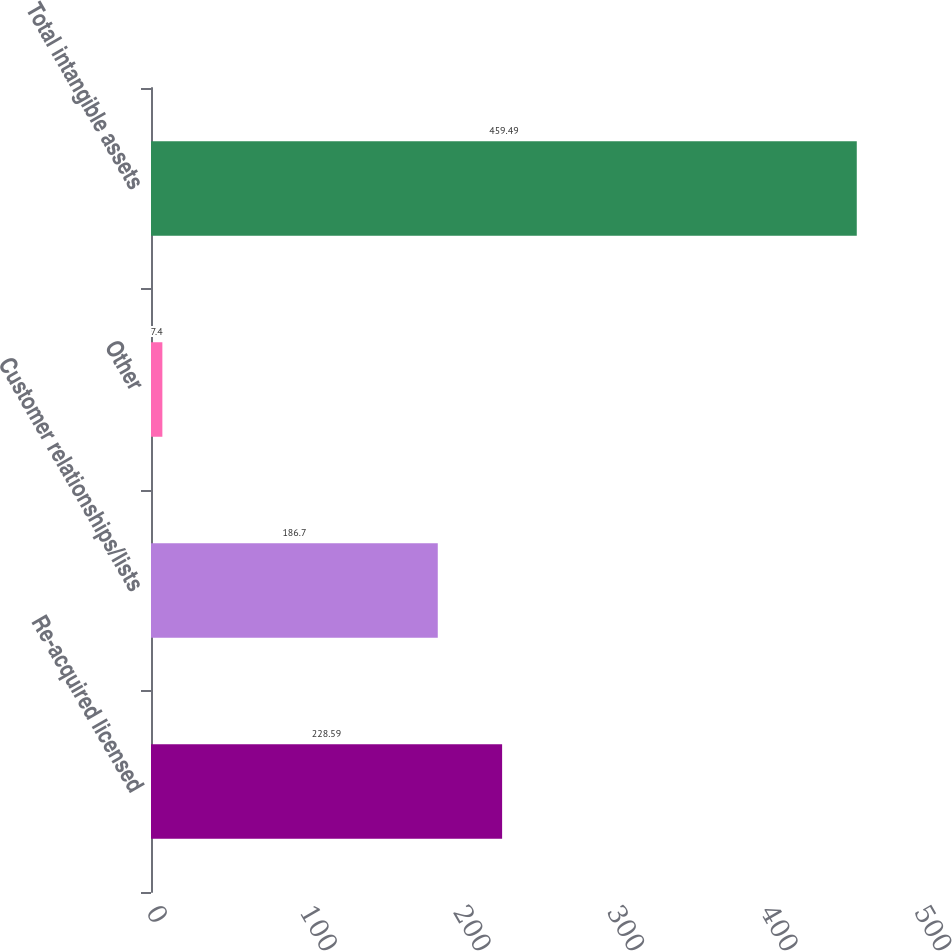Convert chart to OTSL. <chart><loc_0><loc_0><loc_500><loc_500><bar_chart><fcel>Re-acquired licensed<fcel>Customer relationships/lists<fcel>Other<fcel>Total intangible assets<nl><fcel>228.59<fcel>186.7<fcel>7.4<fcel>459.49<nl></chart> 